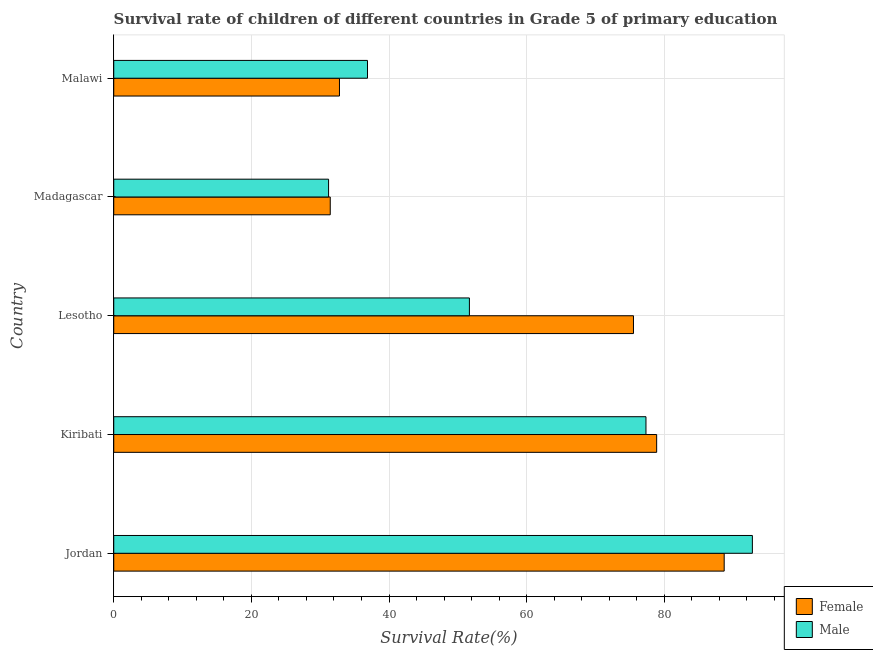How many groups of bars are there?
Provide a succinct answer. 5. How many bars are there on the 3rd tick from the top?
Provide a succinct answer. 2. How many bars are there on the 3rd tick from the bottom?
Your response must be concise. 2. What is the label of the 1st group of bars from the top?
Ensure brevity in your answer.  Malawi. What is the survival rate of female students in primary education in Kiribati?
Offer a very short reply. 78.89. Across all countries, what is the maximum survival rate of male students in primary education?
Provide a succinct answer. 92.8. Across all countries, what is the minimum survival rate of female students in primary education?
Offer a terse response. 31.46. In which country was the survival rate of male students in primary education maximum?
Provide a succinct answer. Jordan. In which country was the survival rate of male students in primary education minimum?
Your answer should be very brief. Madagascar. What is the total survival rate of female students in primary education in the graph?
Offer a very short reply. 307.39. What is the difference between the survival rate of male students in primary education in Lesotho and that in Madagascar?
Your response must be concise. 20.46. What is the difference between the survival rate of male students in primary education in Madagascar and the survival rate of female students in primary education in Lesotho?
Your answer should be very brief. -44.31. What is the average survival rate of male students in primary education per country?
Your response must be concise. 57.98. What is the difference between the survival rate of female students in primary education and survival rate of male students in primary education in Madagascar?
Give a very brief answer. 0.24. In how many countries, is the survival rate of female students in primary education greater than 92 %?
Ensure brevity in your answer.  0. What is the ratio of the survival rate of female students in primary education in Kiribati to that in Lesotho?
Provide a succinct answer. 1.04. Is the survival rate of female students in primary education in Lesotho less than that in Malawi?
Your answer should be very brief. No. Is the difference between the survival rate of female students in primary education in Kiribati and Lesotho greater than the difference between the survival rate of male students in primary education in Kiribati and Lesotho?
Your answer should be compact. No. What is the difference between the highest and the second highest survival rate of male students in primary education?
Provide a short and direct response. 15.46. What is the difference between the highest and the lowest survival rate of male students in primary education?
Offer a very short reply. 61.58. Is the sum of the survival rate of male students in primary education in Jordan and Lesotho greater than the maximum survival rate of female students in primary education across all countries?
Ensure brevity in your answer.  Yes. What does the 2nd bar from the bottom in Lesotho represents?
Your response must be concise. Male. How many bars are there?
Make the answer very short. 10. How many countries are there in the graph?
Make the answer very short. 5. What is the difference between two consecutive major ticks on the X-axis?
Your response must be concise. 20. Are the values on the major ticks of X-axis written in scientific E-notation?
Your answer should be very brief. No. Does the graph contain grids?
Offer a terse response. Yes. Where does the legend appear in the graph?
Provide a succinct answer. Bottom right. How many legend labels are there?
Ensure brevity in your answer.  2. How are the legend labels stacked?
Your response must be concise. Vertical. What is the title of the graph?
Ensure brevity in your answer.  Survival rate of children of different countries in Grade 5 of primary education. What is the label or title of the X-axis?
Offer a very short reply. Survival Rate(%). What is the label or title of the Y-axis?
Your response must be concise. Country. What is the Survival Rate(%) of Female in Jordan?
Make the answer very short. 88.71. What is the Survival Rate(%) in Male in Jordan?
Offer a terse response. 92.8. What is the Survival Rate(%) in Female in Kiribati?
Keep it short and to the point. 78.89. What is the Survival Rate(%) of Male in Kiribati?
Offer a very short reply. 77.34. What is the Survival Rate(%) in Female in Lesotho?
Offer a terse response. 75.52. What is the Survival Rate(%) in Male in Lesotho?
Keep it short and to the point. 51.68. What is the Survival Rate(%) in Female in Madagascar?
Ensure brevity in your answer.  31.46. What is the Survival Rate(%) in Male in Madagascar?
Give a very brief answer. 31.22. What is the Survival Rate(%) of Female in Malawi?
Ensure brevity in your answer.  32.8. What is the Survival Rate(%) of Male in Malawi?
Keep it short and to the point. 36.87. Across all countries, what is the maximum Survival Rate(%) of Female?
Keep it short and to the point. 88.71. Across all countries, what is the maximum Survival Rate(%) of Male?
Your answer should be compact. 92.8. Across all countries, what is the minimum Survival Rate(%) of Female?
Make the answer very short. 31.46. Across all countries, what is the minimum Survival Rate(%) in Male?
Provide a succinct answer. 31.22. What is the total Survival Rate(%) in Female in the graph?
Provide a short and direct response. 307.39. What is the total Survival Rate(%) of Male in the graph?
Your response must be concise. 289.92. What is the difference between the Survival Rate(%) of Female in Jordan and that in Kiribati?
Provide a short and direct response. 9.81. What is the difference between the Survival Rate(%) in Male in Jordan and that in Kiribati?
Offer a terse response. 15.46. What is the difference between the Survival Rate(%) in Female in Jordan and that in Lesotho?
Your answer should be very brief. 13.18. What is the difference between the Survival Rate(%) of Male in Jordan and that in Lesotho?
Your answer should be very brief. 41.12. What is the difference between the Survival Rate(%) of Female in Jordan and that in Madagascar?
Provide a short and direct response. 57.24. What is the difference between the Survival Rate(%) of Male in Jordan and that in Madagascar?
Make the answer very short. 61.58. What is the difference between the Survival Rate(%) of Female in Jordan and that in Malawi?
Provide a succinct answer. 55.9. What is the difference between the Survival Rate(%) of Male in Jordan and that in Malawi?
Your answer should be very brief. 55.93. What is the difference between the Survival Rate(%) in Female in Kiribati and that in Lesotho?
Offer a terse response. 3.37. What is the difference between the Survival Rate(%) of Male in Kiribati and that in Lesotho?
Provide a short and direct response. 25.66. What is the difference between the Survival Rate(%) in Female in Kiribati and that in Madagascar?
Your answer should be compact. 47.43. What is the difference between the Survival Rate(%) in Male in Kiribati and that in Madagascar?
Your answer should be compact. 46.12. What is the difference between the Survival Rate(%) of Female in Kiribati and that in Malawi?
Keep it short and to the point. 46.09. What is the difference between the Survival Rate(%) in Male in Kiribati and that in Malawi?
Offer a terse response. 40.47. What is the difference between the Survival Rate(%) of Female in Lesotho and that in Madagascar?
Make the answer very short. 44.06. What is the difference between the Survival Rate(%) in Male in Lesotho and that in Madagascar?
Your answer should be very brief. 20.46. What is the difference between the Survival Rate(%) in Female in Lesotho and that in Malawi?
Your answer should be compact. 42.72. What is the difference between the Survival Rate(%) of Male in Lesotho and that in Malawi?
Offer a terse response. 14.81. What is the difference between the Survival Rate(%) in Female in Madagascar and that in Malawi?
Provide a short and direct response. -1.34. What is the difference between the Survival Rate(%) of Male in Madagascar and that in Malawi?
Provide a succinct answer. -5.65. What is the difference between the Survival Rate(%) in Female in Jordan and the Survival Rate(%) in Male in Kiribati?
Provide a short and direct response. 11.37. What is the difference between the Survival Rate(%) of Female in Jordan and the Survival Rate(%) of Male in Lesotho?
Provide a short and direct response. 37.02. What is the difference between the Survival Rate(%) in Female in Jordan and the Survival Rate(%) in Male in Madagascar?
Ensure brevity in your answer.  57.49. What is the difference between the Survival Rate(%) of Female in Jordan and the Survival Rate(%) of Male in Malawi?
Provide a succinct answer. 51.83. What is the difference between the Survival Rate(%) in Female in Kiribati and the Survival Rate(%) in Male in Lesotho?
Give a very brief answer. 27.21. What is the difference between the Survival Rate(%) in Female in Kiribati and the Survival Rate(%) in Male in Madagascar?
Ensure brevity in your answer.  47.67. What is the difference between the Survival Rate(%) of Female in Kiribati and the Survival Rate(%) of Male in Malawi?
Your answer should be very brief. 42.02. What is the difference between the Survival Rate(%) of Female in Lesotho and the Survival Rate(%) of Male in Madagascar?
Your answer should be very brief. 44.31. What is the difference between the Survival Rate(%) in Female in Lesotho and the Survival Rate(%) in Male in Malawi?
Make the answer very short. 38.65. What is the difference between the Survival Rate(%) of Female in Madagascar and the Survival Rate(%) of Male in Malawi?
Your answer should be very brief. -5.41. What is the average Survival Rate(%) of Female per country?
Offer a very short reply. 61.48. What is the average Survival Rate(%) in Male per country?
Ensure brevity in your answer.  57.98. What is the difference between the Survival Rate(%) in Female and Survival Rate(%) in Male in Jordan?
Offer a very short reply. -4.1. What is the difference between the Survival Rate(%) in Female and Survival Rate(%) in Male in Kiribati?
Your response must be concise. 1.55. What is the difference between the Survival Rate(%) of Female and Survival Rate(%) of Male in Lesotho?
Offer a terse response. 23.84. What is the difference between the Survival Rate(%) in Female and Survival Rate(%) in Male in Madagascar?
Offer a very short reply. 0.24. What is the difference between the Survival Rate(%) of Female and Survival Rate(%) of Male in Malawi?
Your answer should be very brief. -4.07. What is the ratio of the Survival Rate(%) of Female in Jordan to that in Kiribati?
Your answer should be compact. 1.12. What is the ratio of the Survival Rate(%) of Male in Jordan to that in Kiribati?
Keep it short and to the point. 1.2. What is the ratio of the Survival Rate(%) of Female in Jordan to that in Lesotho?
Make the answer very short. 1.17. What is the ratio of the Survival Rate(%) in Male in Jordan to that in Lesotho?
Provide a short and direct response. 1.8. What is the ratio of the Survival Rate(%) in Female in Jordan to that in Madagascar?
Your answer should be compact. 2.82. What is the ratio of the Survival Rate(%) of Male in Jordan to that in Madagascar?
Your answer should be very brief. 2.97. What is the ratio of the Survival Rate(%) in Female in Jordan to that in Malawi?
Keep it short and to the point. 2.7. What is the ratio of the Survival Rate(%) in Male in Jordan to that in Malawi?
Keep it short and to the point. 2.52. What is the ratio of the Survival Rate(%) of Female in Kiribati to that in Lesotho?
Ensure brevity in your answer.  1.04. What is the ratio of the Survival Rate(%) of Male in Kiribati to that in Lesotho?
Your answer should be very brief. 1.5. What is the ratio of the Survival Rate(%) of Female in Kiribati to that in Madagascar?
Your answer should be very brief. 2.51. What is the ratio of the Survival Rate(%) of Male in Kiribati to that in Madagascar?
Ensure brevity in your answer.  2.48. What is the ratio of the Survival Rate(%) in Female in Kiribati to that in Malawi?
Your answer should be compact. 2.41. What is the ratio of the Survival Rate(%) of Male in Kiribati to that in Malawi?
Provide a succinct answer. 2.1. What is the ratio of the Survival Rate(%) of Female in Lesotho to that in Madagascar?
Give a very brief answer. 2.4. What is the ratio of the Survival Rate(%) of Male in Lesotho to that in Madagascar?
Keep it short and to the point. 1.66. What is the ratio of the Survival Rate(%) in Female in Lesotho to that in Malawi?
Ensure brevity in your answer.  2.3. What is the ratio of the Survival Rate(%) of Male in Lesotho to that in Malawi?
Your answer should be compact. 1.4. What is the ratio of the Survival Rate(%) in Female in Madagascar to that in Malawi?
Provide a short and direct response. 0.96. What is the ratio of the Survival Rate(%) in Male in Madagascar to that in Malawi?
Offer a terse response. 0.85. What is the difference between the highest and the second highest Survival Rate(%) of Female?
Provide a succinct answer. 9.81. What is the difference between the highest and the second highest Survival Rate(%) in Male?
Give a very brief answer. 15.46. What is the difference between the highest and the lowest Survival Rate(%) in Female?
Provide a succinct answer. 57.24. What is the difference between the highest and the lowest Survival Rate(%) in Male?
Keep it short and to the point. 61.58. 